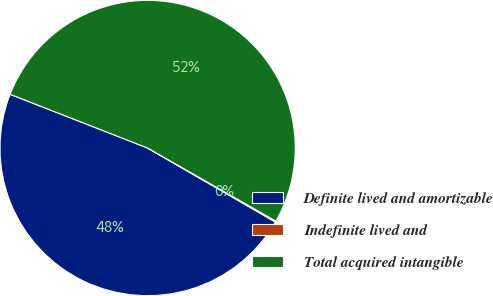Convert chart to OTSL. <chart><loc_0><loc_0><loc_500><loc_500><pie_chart><fcel>Definite lived and amortizable<fcel>Indefinite lived and<fcel>Total acquired intangible<nl><fcel>47.57%<fcel>0.11%<fcel>52.32%<nl></chart> 